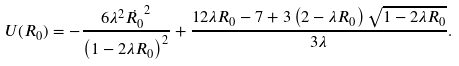<formula> <loc_0><loc_0><loc_500><loc_500>U ( R _ { 0 } ) = - \frac { 6 \lambda ^ { 2 } \dot { R _ { 0 } } ^ { 2 } } { \left ( 1 - 2 \lambda R _ { 0 } \right ) ^ { 2 } } + \frac { 1 2 \lambda R _ { 0 } - 7 + 3 \left ( 2 - \lambda R _ { 0 } \right ) \sqrt { 1 - 2 \lambda R _ { 0 } } } { 3 \lambda } .</formula> 